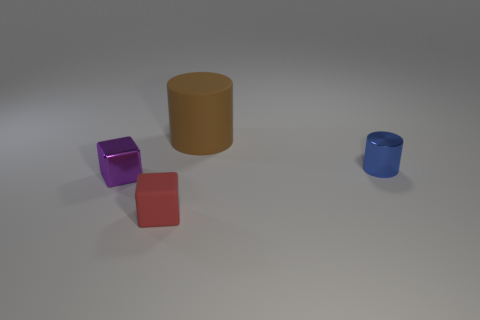Add 2 small purple matte cylinders. How many objects exist? 6 Add 1 tiny red objects. How many tiny red objects are left? 2 Add 4 small purple shiny things. How many small purple shiny things exist? 5 Subtract 1 red blocks. How many objects are left? 3 Subtract all red matte cubes. Subtract all small cubes. How many objects are left? 1 